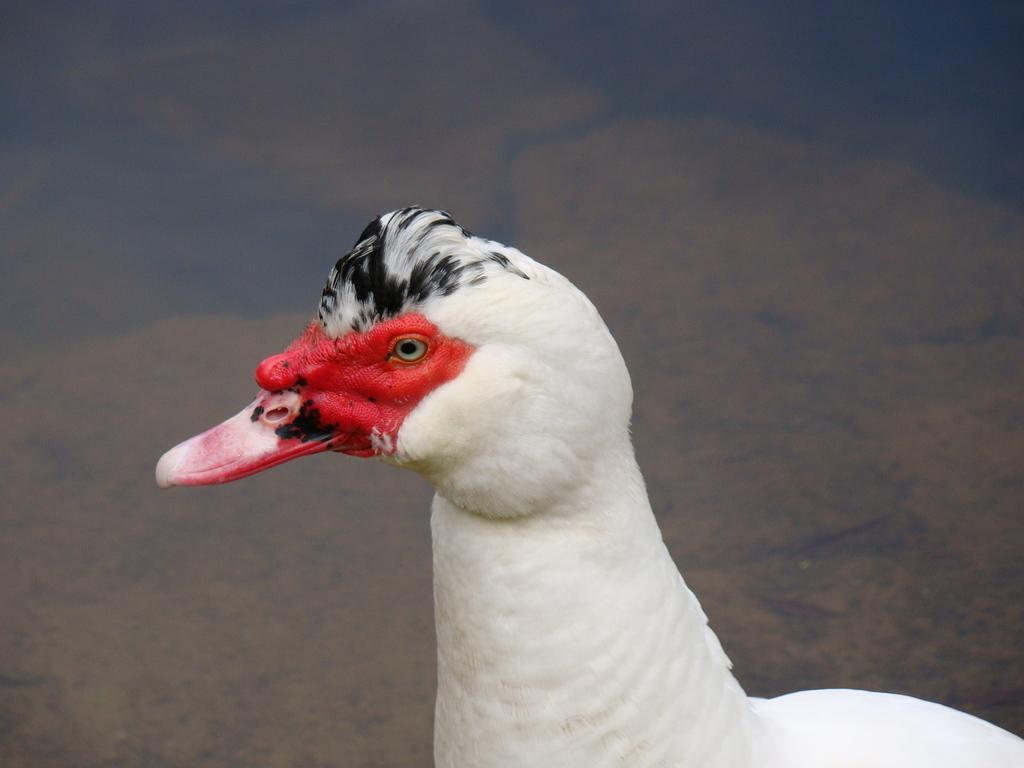How would you summarize this image in a sentence or two? In this image we can see a white bird. 